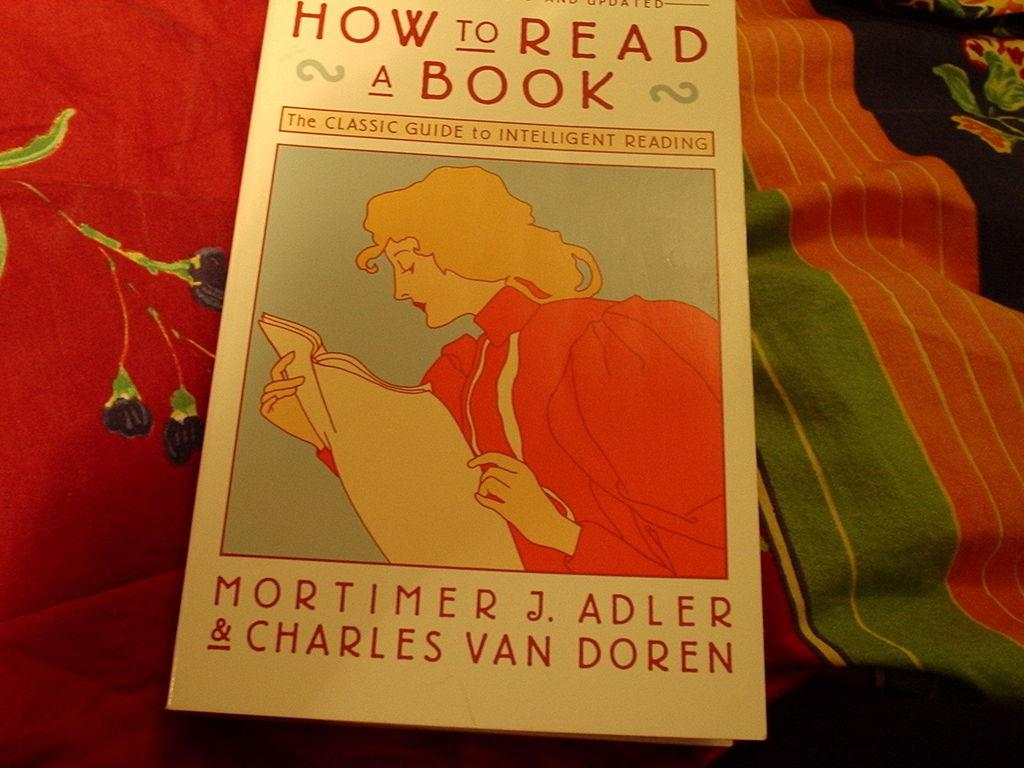<image>
Present a compact description of the photo's key features. A book called How to Read a Book features a person reading on the cover. 